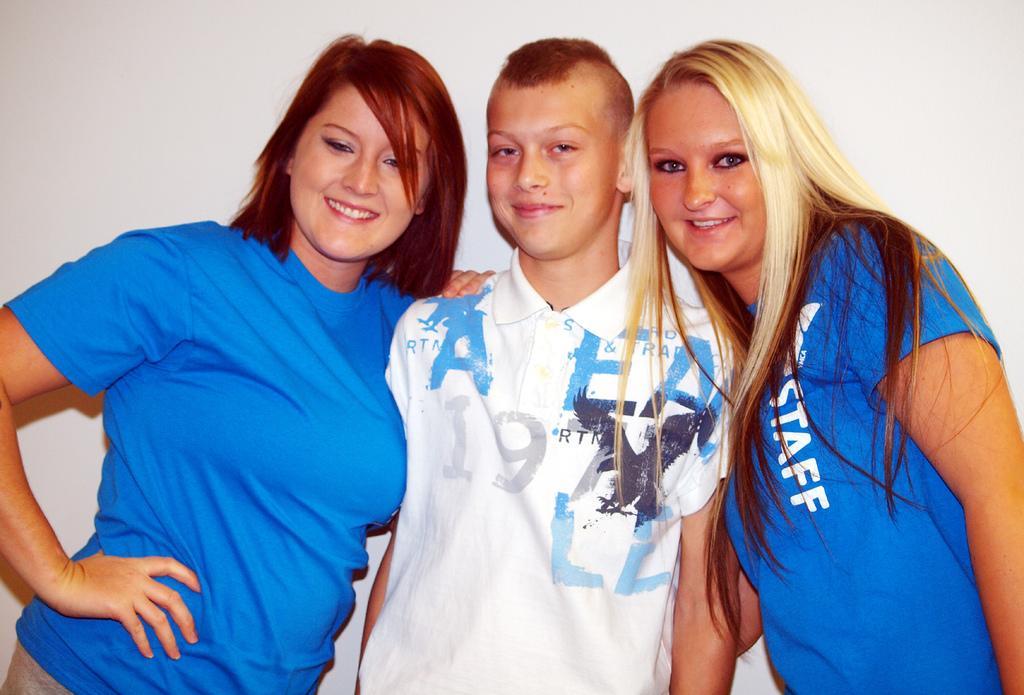Describe this image in one or two sentences. In this image I can see three people standing in the center of the image and posing for the picture. Two women on both sides are wearing blue color T-shirts, one boy in the center is wearing a white color T-shirt with some text. 